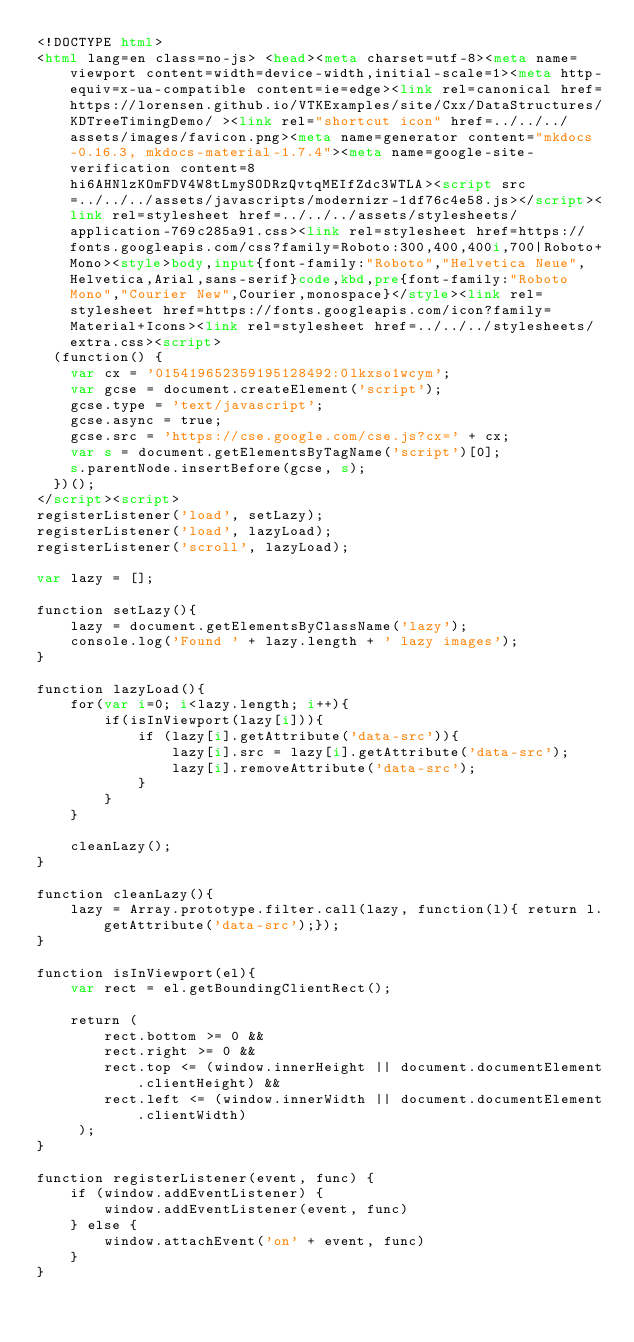Convert code to text. <code><loc_0><loc_0><loc_500><loc_500><_HTML_><!DOCTYPE html>
<html lang=en class=no-js> <head><meta charset=utf-8><meta name=viewport content=width=device-width,initial-scale=1><meta http-equiv=x-ua-compatible content=ie=edge><link rel=canonical href=https://lorensen.github.io/VTKExamples/site/Cxx/DataStructures/KDTreeTimingDemo/ ><link rel="shortcut icon" href=../../../assets/images/favicon.png><meta name=generator content="mkdocs-0.16.3, mkdocs-material-1.7.4"><meta name=google-site-verification content=8hi6AHNlzKOmFDV4W8tLmySODRzQvtqMEIfZdc3WTLA><script src=../../../assets/javascripts/modernizr-1df76c4e58.js></script><link rel=stylesheet href=../../../assets/stylesheets/application-769c285a91.css><link rel=stylesheet href=https://fonts.googleapis.com/css?family=Roboto:300,400,400i,700|Roboto+Mono><style>body,input{font-family:"Roboto","Helvetica Neue",Helvetica,Arial,sans-serif}code,kbd,pre{font-family:"Roboto Mono","Courier New",Courier,monospace}</style><link rel=stylesheet href=https://fonts.googleapis.com/icon?family=Material+Icons><link rel=stylesheet href=../../../stylesheets/extra.css><script>
  (function() {
    var cx = '015419652359195128492:0lkxso1wcym';
    var gcse = document.createElement('script');
    gcse.type = 'text/javascript';
    gcse.async = true;
    gcse.src = 'https://cse.google.com/cse.js?cx=' + cx;
    var s = document.getElementsByTagName('script')[0];
    s.parentNode.insertBefore(gcse, s);
  })();
</script><script>
registerListener('load', setLazy);
registerListener('load', lazyLoad);
registerListener('scroll', lazyLoad);

var lazy = [];

function setLazy(){
    lazy = document.getElementsByClassName('lazy');
    console.log('Found ' + lazy.length + ' lazy images');
} 

function lazyLoad(){
    for(var i=0; i<lazy.length; i++){
        if(isInViewport(lazy[i])){
            if (lazy[i].getAttribute('data-src')){
                lazy[i].src = lazy[i].getAttribute('data-src');
                lazy[i].removeAttribute('data-src');
            }
        }
    }
    
    cleanLazy();
}

function cleanLazy(){
    lazy = Array.prototype.filter.call(lazy, function(l){ return l.getAttribute('data-src');});
}

function isInViewport(el){
    var rect = el.getBoundingClientRect();
    
    return (
        rect.bottom >= 0 && 
        rect.right >= 0 && 
        rect.top <= (window.innerHeight || document.documentElement.clientHeight) && 
        rect.left <= (window.innerWidth || document.documentElement.clientWidth)
     );
}

function registerListener(event, func) {
    if (window.addEventListener) {
        window.addEventListener(event, func)
    } else {
        window.attachEvent('on' + event, func)
    }
}</code> 